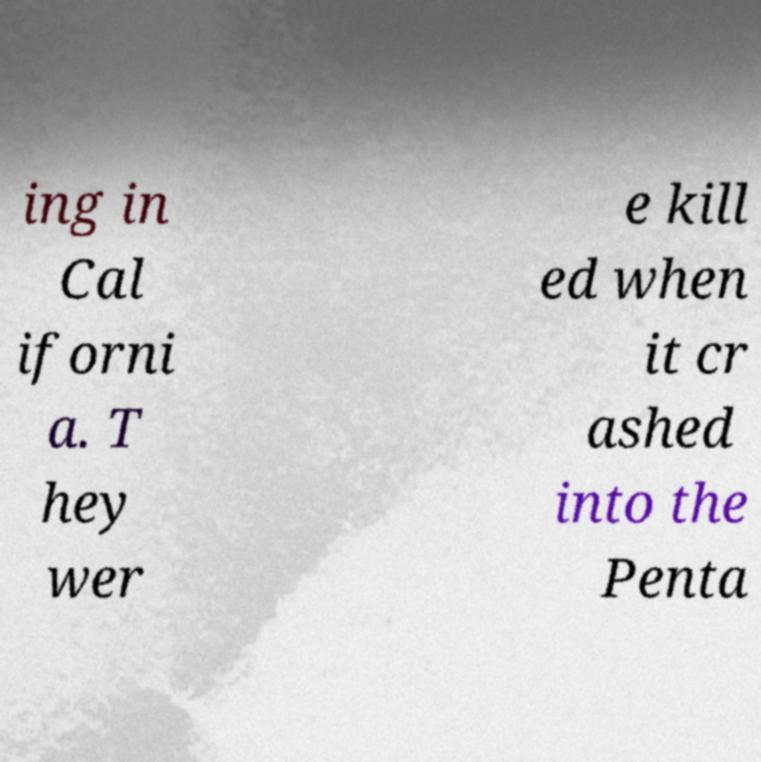Can you read and provide the text displayed in the image?This photo seems to have some interesting text. Can you extract and type it out for me? ing in Cal iforni a. T hey wer e kill ed when it cr ashed into the Penta 